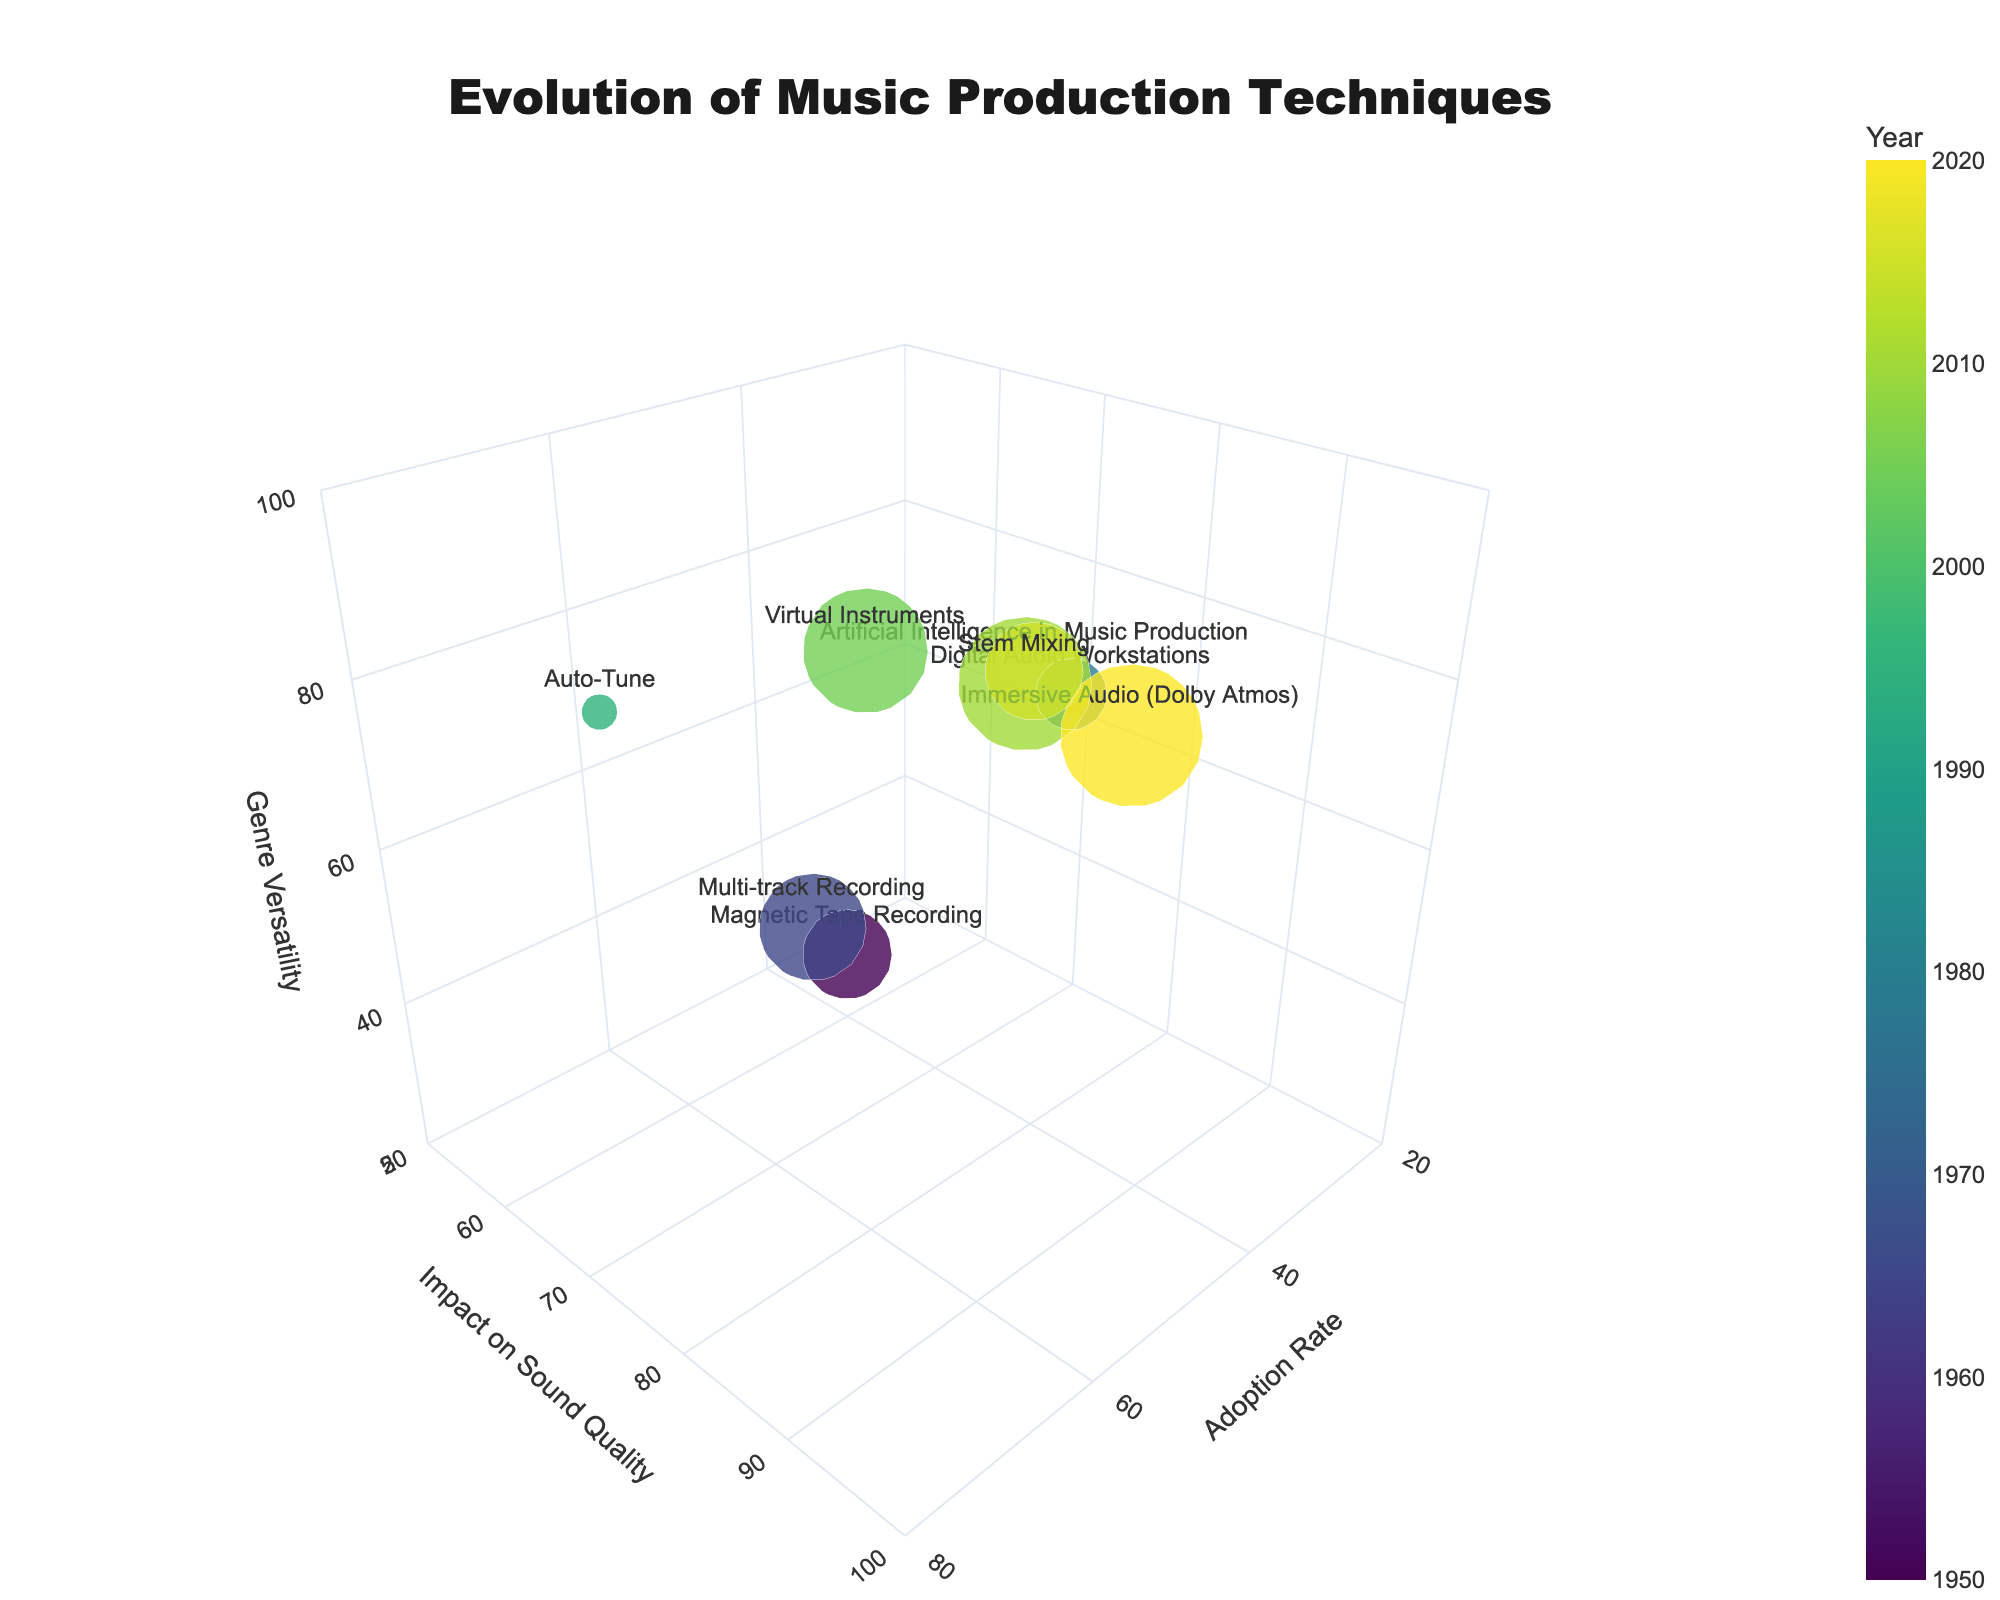What's the title of the figure? The title is usually displayed at the top of the figure. In this case, it's centered and reads clearly to describe the main topic of the visualization.
Answer: Evolution of Music Production Techniques Which technique has the highest impact on sound quality? By looking at the axis labeled "Impact on Sound Quality" and finding the highest value, we can see which technique corresponds to the highest point on this axis.
Answer: Immersive Audio (Dolby Atmos) What is the classical music relevance of the technique with the lowest adoption rate? Identify the technique with the smallest bubble along the "Adoption Rate" axis and check its corresponding classical music relevance value, indicated by the bubble size.
Answer: Digital Audio Workstations, 40 How does the genre versatility of Virtual Instruments compare to Auto-Tune? Locate both techniques on the "Genre Versatility" axis and compare their values.
Answer: Virtual Instruments (90) is greater than Auto-Tune (80) Which technique from the year 2005 has an impact on sound quality greater than 80 and how versatile is it across genres? First, look for the technique from 2005 (Virtual Instruments). Then check if its "Impact on Sound Quality" is greater than 80 and note its "Genre Versatility".
Answer: Virtual Instruments, 90 Name the technique that falls at the intersection of 50 in Adoption Rate and 85 in Impact on Sound Quality. Search the chart for a point where Adoption Rate is 50 and Impact on Sound Quality is 85. The text annotation or hover information should confirm the technique.
Answer: Stem Mixing Calculate the average classical music relevance for techniques introduced before 2000. Add up the classical music relevance values for techniques introduced in 1950, 1965, 1980, and 1995, then divide by the number of these techniques. Calculation: (50 + 60 + 40 + 20) / 4 = 170 / 4 = 42.5
Answer: 42.5 Which technique introduced after 2015 has the greatest genre versatility? Identify the techniques introduced after 2015 and compare their "Genre Versatility" values. Only include those from 2020 in this case.
Answer: Immersive Audio (Dolby Atmos) Find the difference in impact on sound quality between Multi-track Recording (1965) and Auto-Tune (1995). Subtract the "Impact on Sound Quality" value of Auto-Tune from that of Multi-track Recording. Calculation: 70 - 65 = 5
Answer: 5 Which technique has the largest bubble size (indicating classical music relevance), and what is its adoption rate? Find the bubble with the largest size and check its "Adoption Rate".
Answer: Immersive Audio (Dolby Atmos), 45 